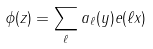Convert formula to latex. <formula><loc_0><loc_0><loc_500><loc_500>\phi ( z ) = \sum _ { \ell } a _ { \ell } ( y ) e ( \ell x )</formula> 